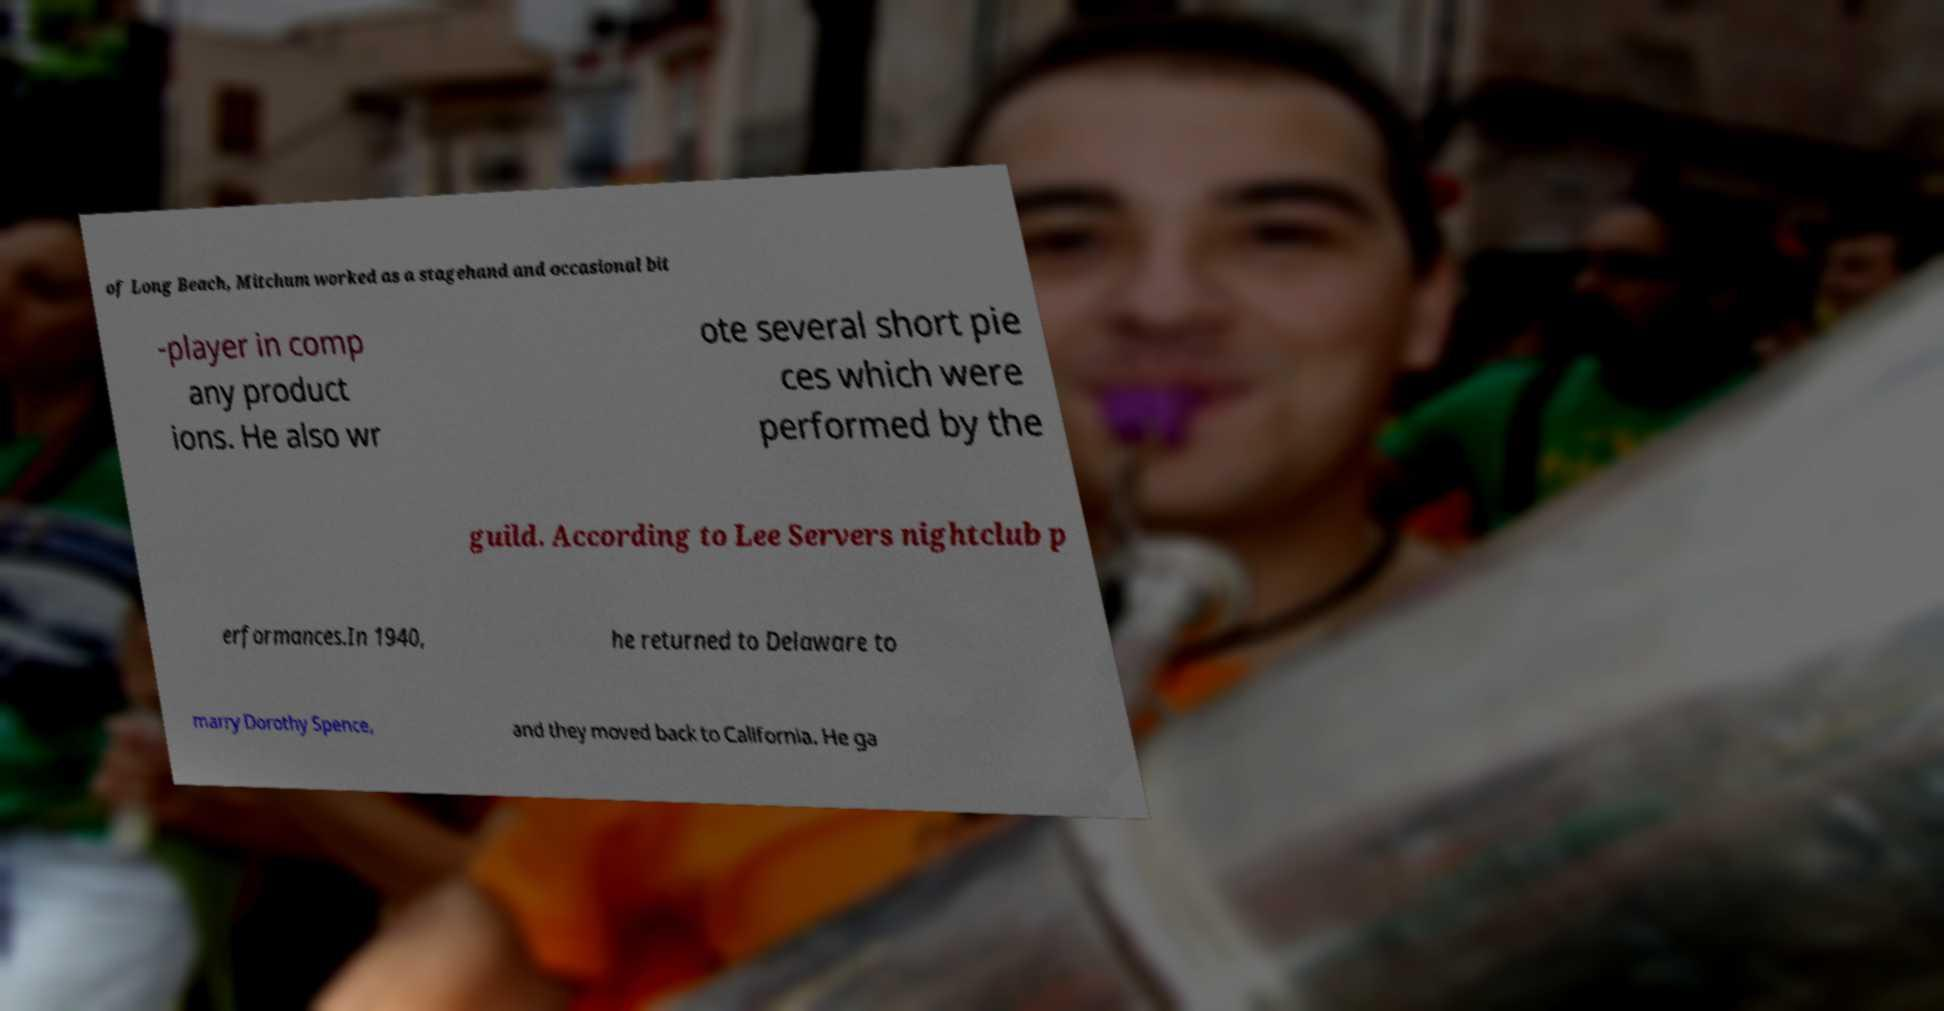There's text embedded in this image that I need extracted. Can you transcribe it verbatim? of Long Beach, Mitchum worked as a stagehand and occasional bit -player in comp any product ions. He also wr ote several short pie ces which were performed by the guild. According to Lee Servers nightclub p erformances.In 1940, he returned to Delaware to marry Dorothy Spence, and they moved back to California. He ga 